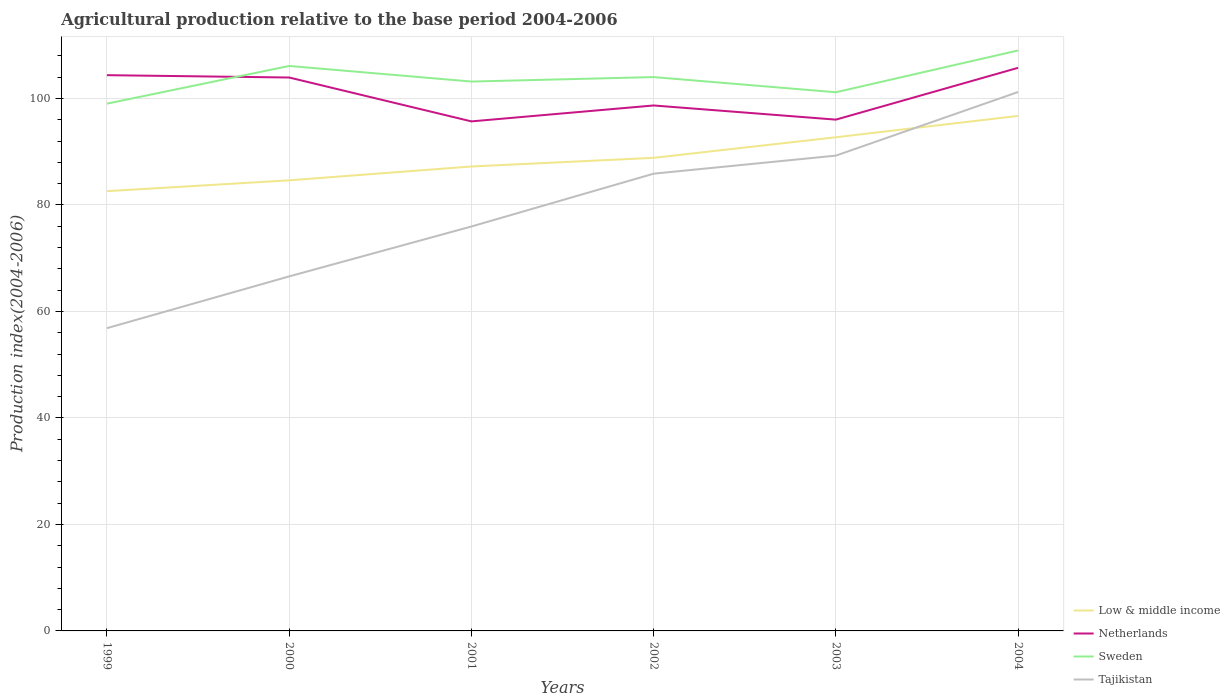Across all years, what is the maximum agricultural production index in Sweden?
Your answer should be very brief. 99.02. In which year was the agricultural production index in Tajikistan maximum?
Give a very brief answer. 1999. What is the total agricultural production index in Sweden in the graph?
Keep it short and to the point. -9.99. What is the difference between the highest and the second highest agricultural production index in Netherlands?
Offer a very short reply. 10.06. What is the difference between the highest and the lowest agricultural production index in Low & middle income?
Offer a very short reply. 3. Is the agricultural production index in Low & middle income strictly greater than the agricultural production index in Netherlands over the years?
Provide a short and direct response. Yes. What is the difference between two consecutive major ticks on the Y-axis?
Ensure brevity in your answer.  20. Are the values on the major ticks of Y-axis written in scientific E-notation?
Keep it short and to the point. No. Does the graph contain any zero values?
Your answer should be very brief. No. Does the graph contain grids?
Make the answer very short. Yes. Where does the legend appear in the graph?
Keep it short and to the point. Bottom right. How many legend labels are there?
Ensure brevity in your answer.  4. How are the legend labels stacked?
Provide a short and direct response. Vertical. What is the title of the graph?
Offer a terse response. Agricultural production relative to the base period 2004-2006. What is the label or title of the X-axis?
Your answer should be compact. Years. What is the label or title of the Y-axis?
Offer a very short reply. Production index(2004-2006). What is the Production index(2004-2006) in Low & middle income in 1999?
Make the answer very short. 82.59. What is the Production index(2004-2006) of Netherlands in 1999?
Your answer should be compact. 104.37. What is the Production index(2004-2006) in Sweden in 1999?
Offer a very short reply. 99.02. What is the Production index(2004-2006) of Tajikistan in 1999?
Ensure brevity in your answer.  56.86. What is the Production index(2004-2006) in Low & middle income in 2000?
Your response must be concise. 84.62. What is the Production index(2004-2006) in Netherlands in 2000?
Provide a succinct answer. 103.93. What is the Production index(2004-2006) of Sweden in 2000?
Provide a short and direct response. 106.1. What is the Production index(2004-2006) in Tajikistan in 2000?
Give a very brief answer. 66.58. What is the Production index(2004-2006) of Low & middle income in 2001?
Give a very brief answer. 87.22. What is the Production index(2004-2006) of Netherlands in 2001?
Offer a terse response. 95.69. What is the Production index(2004-2006) of Sweden in 2001?
Offer a very short reply. 103.17. What is the Production index(2004-2006) in Tajikistan in 2001?
Provide a short and direct response. 75.95. What is the Production index(2004-2006) of Low & middle income in 2002?
Ensure brevity in your answer.  88.85. What is the Production index(2004-2006) in Netherlands in 2002?
Provide a succinct answer. 98.68. What is the Production index(2004-2006) of Sweden in 2002?
Give a very brief answer. 104.01. What is the Production index(2004-2006) of Tajikistan in 2002?
Your answer should be very brief. 85.87. What is the Production index(2004-2006) in Low & middle income in 2003?
Your answer should be compact. 92.71. What is the Production index(2004-2006) of Netherlands in 2003?
Provide a short and direct response. 96.02. What is the Production index(2004-2006) of Sweden in 2003?
Make the answer very short. 101.16. What is the Production index(2004-2006) in Tajikistan in 2003?
Your answer should be very brief. 89.26. What is the Production index(2004-2006) of Low & middle income in 2004?
Your answer should be very brief. 96.72. What is the Production index(2004-2006) of Netherlands in 2004?
Offer a terse response. 105.75. What is the Production index(2004-2006) of Sweden in 2004?
Make the answer very short. 109.01. What is the Production index(2004-2006) in Tajikistan in 2004?
Keep it short and to the point. 101.21. Across all years, what is the maximum Production index(2004-2006) of Low & middle income?
Make the answer very short. 96.72. Across all years, what is the maximum Production index(2004-2006) of Netherlands?
Your answer should be very brief. 105.75. Across all years, what is the maximum Production index(2004-2006) in Sweden?
Make the answer very short. 109.01. Across all years, what is the maximum Production index(2004-2006) of Tajikistan?
Ensure brevity in your answer.  101.21. Across all years, what is the minimum Production index(2004-2006) of Low & middle income?
Your response must be concise. 82.59. Across all years, what is the minimum Production index(2004-2006) of Netherlands?
Keep it short and to the point. 95.69. Across all years, what is the minimum Production index(2004-2006) of Sweden?
Make the answer very short. 99.02. Across all years, what is the minimum Production index(2004-2006) of Tajikistan?
Your answer should be compact. 56.86. What is the total Production index(2004-2006) in Low & middle income in the graph?
Keep it short and to the point. 532.7. What is the total Production index(2004-2006) in Netherlands in the graph?
Offer a terse response. 604.44. What is the total Production index(2004-2006) of Sweden in the graph?
Your answer should be compact. 622.47. What is the total Production index(2004-2006) of Tajikistan in the graph?
Give a very brief answer. 475.73. What is the difference between the Production index(2004-2006) in Low & middle income in 1999 and that in 2000?
Provide a short and direct response. -2.04. What is the difference between the Production index(2004-2006) of Netherlands in 1999 and that in 2000?
Offer a terse response. 0.44. What is the difference between the Production index(2004-2006) in Sweden in 1999 and that in 2000?
Make the answer very short. -7.08. What is the difference between the Production index(2004-2006) in Tajikistan in 1999 and that in 2000?
Provide a succinct answer. -9.72. What is the difference between the Production index(2004-2006) in Low & middle income in 1999 and that in 2001?
Your answer should be very brief. -4.63. What is the difference between the Production index(2004-2006) of Netherlands in 1999 and that in 2001?
Your answer should be compact. 8.68. What is the difference between the Production index(2004-2006) of Sweden in 1999 and that in 2001?
Your answer should be compact. -4.15. What is the difference between the Production index(2004-2006) of Tajikistan in 1999 and that in 2001?
Your answer should be very brief. -19.09. What is the difference between the Production index(2004-2006) in Low & middle income in 1999 and that in 2002?
Offer a terse response. -6.26. What is the difference between the Production index(2004-2006) of Netherlands in 1999 and that in 2002?
Give a very brief answer. 5.69. What is the difference between the Production index(2004-2006) of Sweden in 1999 and that in 2002?
Your answer should be compact. -4.99. What is the difference between the Production index(2004-2006) in Tajikistan in 1999 and that in 2002?
Provide a succinct answer. -29.01. What is the difference between the Production index(2004-2006) of Low & middle income in 1999 and that in 2003?
Give a very brief answer. -10.12. What is the difference between the Production index(2004-2006) in Netherlands in 1999 and that in 2003?
Make the answer very short. 8.35. What is the difference between the Production index(2004-2006) of Sweden in 1999 and that in 2003?
Make the answer very short. -2.14. What is the difference between the Production index(2004-2006) in Tajikistan in 1999 and that in 2003?
Keep it short and to the point. -32.4. What is the difference between the Production index(2004-2006) of Low & middle income in 1999 and that in 2004?
Offer a terse response. -14.13. What is the difference between the Production index(2004-2006) in Netherlands in 1999 and that in 2004?
Provide a short and direct response. -1.38. What is the difference between the Production index(2004-2006) in Sweden in 1999 and that in 2004?
Your response must be concise. -9.99. What is the difference between the Production index(2004-2006) in Tajikistan in 1999 and that in 2004?
Your answer should be compact. -44.35. What is the difference between the Production index(2004-2006) of Low & middle income in 2000 and that in 2001?
Provide a succinct answer. -2.6. What is the difference between the Production index(2004-2006) of Netherlands in 2000 and that in 2001?
Your answer should be compact. 8.24. What is the difference between the Production index(2004-2006) in Sweden in 2000 and that in 2001?
Keep it short and to the point. 2.93. What is the difference between the Production index(2004-2006) of Tajikistan in 2000 and that in 2001?
Keep it short and to the point. -9.37. What is the difference between the Production index(2004-2006) in Low & middle income in 2000 and that in 2002?
Make the answer very short. -4.23. What is the difference between the Production index(2004-2006) in Netherlands in 2000 and that in 2002?
Provide a short and direct response. 5.25. What is the difference between the Production index(2004-2006) of Sweden in 2000 and that in 2002?
Provide a short and direct response. 2.09. What is the difference between the Production index(2004-2006) in Tajikistan in 2000 and that in 2002?
Your answer should be very brief. -19.29. What is the difference between the Production index(2004-2006) in Low & middle income in 2000 and that in 2003?
Ensure brevity in your answer.  -8.09. What is the difference between the Production index(2004-2006) in Netherlands in 2000 and that in 2003?
Ensure brevity in your answer.  7.91. What is the difference between the Production index(2004-2006) in Sweden in 2000 and that in 2003?
Ensure brevity in your answer.  4.94. What is the difference between the Production index(2004-2006) in Tajikistan in 2000 and that in 2003?
Provide a succinct answer. -22.68. What is the difference between the Production index(2004-2006) of Low & middle income in 2000 and that in 2004?
Keep it short and to the point. -12.1. What is the difference between the Production index(2004-2006) in Netherlands in 2000 and that in 2004?
Offer a terse response. -1.82. What is the difference between the Production index(2004-2006) in Sweden in 2000 and that in 2004?
Make the answer very short. -2.91. What is the difference between the Production index(2004-2006) of Tajikistan in 2000 and that in 2004?
Give a very brief answer. -34.63. What is the difference between the Production index(2004-2006) of Low & middle income in 2001 and that in 2002?
Provide a succinct answer. -1.63. What is the difference between the Production index(2004-2006) of Netherlands in 2001 and that in 2002?
Offer a terse response. -2.99. What is the difference between the Production index(2004-2006) of Sweden in 2001 and that in 2002?
Your answer should be compact. -0.84. What is the difference between the Production index(2004-2006) in Tajikistan in 2001 and that in 2002?
Provide a succinct answer. -9.92. What is the difference between the Production index(2004-2006) in Low & middle income in 2001 and that in 2003?
Provide a succinct answer. -5.49. What is the difference between the Production index(2004-2006) of Netherlands in 2001 and that in 2003?
Ensure brevity in your answer.  -0.33. What is the difference between the Production index(2004-2006) in Sweden in 2001 and that in 2003?
Offer a very short reply. 2.01. What is the difference between the Production index(2004-2006) of Tajikistan in 2001 and that in 2003?
Your answer should be compact. -13.31. What is the difference between the Production index(2004-2006) in Low & middle income in 2001 and that in 2004?
Give a very brief answer. -9.5. What is the difference between the Production index(2004-2006) of Netherlands in 2001 and that in 2004?
Offer a terse response. -10.06. What is the difference between the Production index(2004-2006) in Sweden in 2001 and that in 2004?
Your answer should be very brief. -5.84. What is the difference between the Production index(2004-2006) in Tajikistan in 2001 and that in 2004?
Make the answer very short. -25.26. What is the difference between the Production index(2004-2006) of Low & middle income in 2002 and that in 2003?
Your response must be concise. -3.86. What is the difference between the Production index(2004-2006) in Netherlands in 2002 and that in 2003?
Make the answer very short. 2.66. What is the difference between the Production index(2004-2006) in Sweden in 2002 and that in 2003?
Your response must be concise. 2.85. What is the difference between the Production index(2004-2006) of Tajikistan in 2002 and that in 2003?
Your answer should be compact. -3.39. What is the difference between the Production index(2004-2006) of Low & middle income in 2002 and that in 2004?
Provide a short and direct response. -7.87. What is the difference between the Production index(2004-2006) in Netherlands in 2002 and that in 2004?
Your answer should be very brief. -7.07. What is the difference between the Production index(2004-2006) in Sweden in 2002 and that in 2004?
Offer a very short reply. -5. What is the difference between the Production index(2004-2006) in Tajikistan in 2002 and that in 2004?
Provide a short and direct response. -15.34. What is the difference between the Production index(2004-2006) in Low & middle income in 2003 and that in 2004?
Ensure brevity in your answer.  -4.01. What is the difference between the Production index(2004-2006) of Netherlands in 2003 and that in 2004?
Your answer should be compact. -9.73. What is the difference between the Production index(2004-2006) of Sweden in 2003 and that in 2004?
Your answer should be compact. -7.85. What is the difference between the Production index(2004-2006) of Tajikistan in 2003 and that in 2004?
Provide a succinct answer. -11.95. What is the difference between the Production index(2004-2006) of Low & middle income in 1999 and the Production index(2004-2006) of Netherlands in 2000?
Keep it short and to the point. -21.34. What is the difference between the Production index(2004-2006) of Low & middle income in 1999 and the Production index(2004-2006) of Sweden in 2000?
Make the answer very short. -23.51. What is the difference between the Production index(2004-2006) in Low & middle income in 1999 and the Production index(2004-2006) in Tajikistan in 2000?
Your answer should be compact. 16.01. What is the difference between the Production index(2004-2006) of Netherlands in 1999 and the Production index(2004-2006) of Sweden in 2000?
Your answer should be very brief. -1.73. What is the difference between the Production index(2004-2006) of Netherlands in 1999 and the Production index(2004-2006) of Tajikistan in 2000?
Keep it short and to the point. 37.79. What is the difference between the Production index(2004-2006) in Sweden in 1999 and the Production index(2004-2006) in Tajikistan in 2000?
Provide a short and direct response. 32.44. What is the difference between the Production index(2004-2006) in Low & middle income in 1999 and the Production index(2004-2006) in Netherlands in 2001?
Your answer should be very brief. -13.1. What is the difference between the Production index(2004-2006) of Low & middle income in 1999 and the Production index(2004-2006) of Sweden in 2001?
Keep it short and to the point. -20.58. What is the difference between the Production index(2004-2006) of Low & middle income in 1999 and the Production index(2004-2006) of Tajikistan in 2001?
Provide a short and direct response. 6.64. What is the difference between the Production index(2004-2006) in Netherlands in 1999 and the Production index(2004-2006) in Tajikistan in 2001?
Provide a short and direct response. 28.42. What is the difference between the Production index(2004-2006) of Sweden in 1999 and the Production index(2004-2006) of Tajikistan in 2001?
Make the answer very short. 23.07. What is the difference between the Production index(2004-2006) in Low & middle income in 1999 and the Production index(2004-2006) in Netherlands in 2002?
Provide a succinct answer. -16.09. What is the difference between the Production index(2004-2006) in Low & middle income in 1999 and the Production index(2004-2006) in Sweden in 2002?
Provide a succinct answer. -21.42. What is the difference between the Production index(2004-2006) in Low & middle income in 1999 and the Production index(2004-2006) in Tajikistan in 2002?
Offer a terse response. -3.28. What is the difference between the Production index(2004-2006) of Netherlands in 1999 and the Production index(2004-2006) of Sweden in 2002?
Offer a very short reply. 0.36. What is the difference between the Production index(2004-2006) of Sweden in 1999 and the Production index(2004-2006) of Tajikistan in 2002?
Provide a short and direct response. 13.15. What is the difference between the Production index(2004-2006) of Low & middle income in 1999 and the Production index(2004-2006) of Netherlands in 2003?
Ensure brevity in your answer.  -13.43. What is the difference between the Production index(2004-2006) in Low & middle income in 1999 and the Production index(2004-2006) in Sweden in 2003?
Your answer should be compact. -18.57. What is the difference between the Production index(2004-2006) of Low & middle income in 1999 and the Production index(2004-2006) of Tajikistan in 2003?
Keep it short and to the point. -6.67. What is the difference between the Production index(2004-2006) in Netherlands in 1999 and the Production index(2004-2006) in Sweden in 2003?
Provide a succinct answer. 3.21. What is the difference between the Production index(2004-2006) in Netherlands in 1999 and the Production index(2004-2006) in Tajikistan in 2003?
Give a very brief answer. 15.11. What is the difference between the Production index(2004-2006) in Sweden in 1999 and the Production index(2004-2006) in Tajikistan in 2003?
Offer a terse response. 9.76. What is the difference between the Production index(2004-2006) of Low & middle income in 1999 and the Production index(2004-2006) of Netherlands in 2004?
Provide a short and direct response. -23.16. What is the difference between the Production index(2004-2006) in Low & middle income in 1999 and the Production index(2004-2006) in Sweden in 2004?
Provide a succinct answer. -26.42. What is the difference between the Production index(2004-2006) of Low & middle income in 1999 and the Production index(2004-2006) of Tajikistan in 2004?
Ensure brevity in your answer.  -18.62. What is the difference between the Production index(2004-2006) in Netherlands in 1999 and the Production index(2004-2006) in Sweden in 2004?
Your answer should be very brief. -4.64. What is the difference between the Production index(2004-2006) in Netherlands in 1999 and the Production index(2004-2006) in Tajikistan in 2004?
Ensure brevity in your answer.  3.16. What is the difference between the Production index(2004-2006) of Sweden in 1999 and the Production index(2004-2006) of Tajikistan in 2004?
Your response must be concise. -2.19. What is the difference between the Production index(2004-2006) of Low & middle income in 2000 and the Production index(2004-2006) of Netherlands in 2001?
Offer a terse response. -11.07. What is the difference between the Production index(2004-2006) in Low & middle income in 2000 and the Production index(2004-2006) in Sweden in 2001?
Offer a very short reply. -18.55. What is the difference between the Production index(2004-2006) of Low & middle income in 2000 and the Production index(2004-2006) of Tajikistan in 2001?
Keep it short and to the point. 8.67. What is the difference between the Production index(2004-2006) of Netherlands in 2000 and the Production index(2004-2006) of Sweden in 2001?
Offer a terse response. 0.76. What is the difference between the Production index(2004-2006) in Netherlands in 2000 and the Production index(2004-2006) in Tajikistan in 2001?
Give a very brief answer. 27.98. What is the difference between the Production index(2004-2006) of Sweden in 2000 and the Production index(2004-2006) of Tajikistan in 2001?
Give a very brief answer. 30.15. What is the difference between the Production index(2004-2006) of Low & middle income in 2000 and the Production index(2004-2006) of Netherlands in 2002?
Make the answer very short. -14.06. What is the difference between the Production index(2004-2006) of Low & middle income in 2000 and the Production index(2004-2006) of Sweden in 2002?
Offer a terse response. -19.39. What is the difference between the Production index(2004-2006) in Low & middle income in 2000 and the Production index(2004-2006) in Tajikistan in 2002?
Your answer should be compact. -1.25. What is the difference between the Production index(2004-2006) in Netherlands in 2000 and the Production index(2004-2006) in Sweden in 2002?
Give a very brief answer. -0.08. What is the difference between the Production index(2004-2006) in Netherlands in 2000 and the Production index(2004-2006) in Tajikistan in 2002?
Make the answer very short. 18.06. What is the difference between the Production index(2004-2006) of Sweden in 2000 and the Production index(2004-2006) of Tajikistan in 2002?
Your answer should be very brief. 20.23. What is the difference between the Production index(2004-2006) of Low & middle income in 2000 and the Production index(2004-2006) of Netherlands in 2003?
Offer a terse response. -11.4. What is the difference between the Production index(2004-2006) in Low & middle income in 2000 and the Production index(2004-2006) in Sweden in 2003?
Your answer should be very brief. -16.54. What is the difference between the Production index(2004-2006) of Low & middle income in 2000 and the Production index(2004-2006) of Tajikistan in 2003?
Make the answer very short. -4.64. What is the difference between the Production index(2004-2006) of Netherlands in 2000 and the Production index(2004-2006) of Sweden in 2003?
Your answer should be very brief. 2.77. What is the difference between the Production index(2004-2006) of Netherlands in 2000 and the Production index(2004-2006) of Tajikistan in 2003?
Offer a terse response. 14.67. What is the difference between the Production index(2004-2006) in Sweden in 2000 and the Production index(2004-2006) in Tajikistan in 2003?
Your answer should be compact. 16.84. What is the difference between the Production index(2004-2006) in Low & middle income in 2000 and the Production index(2004-2006) in Netherlands in 2004?
Keep it short and to the point. -21.13. What is the difference between the Production index(2004-2006) of Low & middle income in 2000 and the Production index(2004-2006) of Sweden in 2004?
Offer a terse response. -24.39. What is the difference between the Production index(2004-2006) in Low & middle income in 2000 and the Production index(2004-2006) in Tajikistan in 2004?
Give a very brief answer. -16.59. What is the difference between the Production index(2004-2006) in Netherlands in 2000 and the Production index(2004-2006) in Sweden in 2004?
Your answer should be compact. -5.08. What is the difference between the Production index(2004-2006) in Netherlands in 2000 and the Production index(2004-2006) in Tajikistan in 2004?
Offer a terse response. 2.72. What is the difference between the Production index(2004-2006) in Sweden in 2000 and the Production index(2004-2006) in Tajikistan in 2004?
Your answer should be compact. 4.89. What is the difference between the Production index(2004-2006) in Low & middle income in 2001 and the Production index(2004-2006) in Netherlands in 2002?
Provide a short and direct response. -11.46. What is the difference between the Production index(2004-2006) in Low & middle income in 2001 and the Production index(2004-2006) in Sweden in 2002?
Make the answer very short. -16.79. What is the difference between the Production index(2004-2006) of Low & middle income in 2001 and the Production index(2004-2006) of Tajikistan in 2002?
Give a very brief answer. 1.35. What is the difference between the Production index(2004-2006) in Netherlands in 2001 and the Production index(2004-2006) in Sweden in 2002?
Keep it short and to the point. -8.32. What is the difference between the Production index(2004-2006) of Netherlands in 2001 and the Production index(2004-2006) of Tajikistan in 2002?
Provide a succinct answer. 9.82. What is the difference between the Production index(2004-2006) of Sweden in 2001 and the Production index(2004-2006) of Tajikistan in 2002?
Keep it short and to the point. 17.3. What is the difference between the Production index(2004-2006) of Low & middle income in 2001 and the Production index(2004-2006) of Netherlands in 2003?
Ensure brevity in your answer.  -8.8. What is the difference between the Production index(2004-2006) in Low & middle income in 2001 and the Production index(2004-2006) in Sweden in 2003?
Give a very brief answer. -13.94. What is the difference between the Production index(2004-2006) in Low & middle income in 2001 and the Production index(2004-2006) in Tajikistan in 2003?
Make the answer very short. -2.04. What is the difference between the Production index(2004-2006) in Netherlands in 2001 and the Production index(2004-2006) in Sweden in 2003?
Your answer should be very brief. -5.47. What is the difference between the Production index(2004-2006) in Netherlands in 2001 and the Production index(2004-2006) in Tajikistan in 2003?
Your answer should be compact. 6.43. What is the difference between the Production index(2004-2006) of Sweden in 2001 and the Production index(2004-2006) of Tajikistan in 2003?
Provide a succinct answer. 13.91. What is the difference between the Production index(2004-2006) of Low & middle income in 2001 and the Production index(2004-2006) of Netherlands in 2004?
Provide a succinct answer. -18.53. What is the difference between the Production index(2004-2006) in Low & middle income in 2001 and the Production index(2004-2006) in Sweden in 2004?
Keep it short and to the point. -21.79. What is the difference between the Production index(2004-2006) in Low & middle income in 2001 and the Production index(2004-2006) in Tajikistan in 2004?
Your answer should be very brief. -13.99. What is the difference between the Production index(2004-2006) of Netherlands in 2001 and the Production index(2004-2006) of Sweden in 2004?
Give a very brief answer. -13.32. What is the difference between the Production index(2004-2006) of Netherlands in 2001 and the Production index(2004-2006) of Tajikistan in 2004?
Provide a succinct answer. -5.52. What is the difference between the Production index(2004-2006) in Sweden in 2001 and the Production index(2004-2006) in Tajikistan in 2004?
Keep it short and to the point. 1.96. What is the difference between the Production index(2004-2006) of Low & middle income in 2002 and the Production index(2004-2006) of Netherlands in 2003?
Ensure brevity in your answer.  -7.17. What is the difference between the Production index(2004-2006) in Low & middle income in 2002 and the Production index(2004-2006) in Sweden in 2003?
Provide a succinct answer. -12.31. What is the difference between the Production index(2004-2006) in Low & middle income in 2002 and the Production index(2004-2006) in Tajikistan in 2003?
Offer a very short reply. -0.41. What is the difference between the Production index(2004-2006) in Netherlands in 2002 and the Production index(2004-2006) in Sweden in 2003?
Your answer should be very brief. -2.48. What is the difference between the Production index(2004-2006) of Netherlands in 2002 and the Production index(2004-2006) of Tajikistan in 2003?
Offer a terse response. 9.42. What is the difference between the Production index(2004-2006) in Sweden in 2002 and the Production index(2004-2006) in Tajikistan in 2003?
Your response must be concise. 14.75. What is the difference between the Production index(2004-2006) of Low & middle income in 2002 and the Production index(2004-2006) of Netherlands in 2004?
Keep it short and to the point. -16.9. What is the difference between the Production index(2004-2006) of Low & middle income in 2002 and the Production index(2004-2006) of Sweden in 2004?
Ensure brevity in your answer.  -20.16. What is the difference between the Production index(2004-2006) of Low & middle income in 2002 and the Production index(2004-2006) of Tajikistan in 2004?
Keep it short and to the point. -12.36. What is the difference between the Production index(2004-2006) of Netherlands in 2002 and the Production index(2004-2006) of Sweden in 2004?
Make the answer very short. -10.33. What is the difference between the Production index(2004-2006) of Netherlands in 2002 and the Production index(2004-2006) of Tajikistan in 2004?
Ensure brevity in your answer.  -2.53. What is the difference between the Production index(2004-2006) of Sweden in 2002 and the Production index(2004-2006) of Tajikistan in 2004?
Offer a very short reply. 2.8. What is the difference between the Production index(2004-2006) in Low & middle income in 2003 and the Production index(2004-2006) in Netherlands in 2004?
Keep it short and to the point. -13.04. What is the difference between the Production index(2004-2006) of Low & middle income in 2003 and the Production index(2004-2006) of Sweden in 2004?
Give a very brief answer. -16.3. What is the difference between the Production index(2004-2006) of Low & middle income in 2003 and the Production index(2004-2006) of Tajikistan in 2004?
Your response must be concise. -8.5. What is the difference between the Production index(2004-2006) in Netherlands in 2003 and the Production index(2004-2006) in Sweden in 2004?
Ensure brevity in your answer.  -12.99. What is the difference between the Production index(2004-2006) of Netherlands in 2003 and the Production index(2004-2006) of Tajikistan in 2004?
Provide a succinct answer. -5.19. What is the average Production index(2004-2006) of Low & middle income per year?
Give a very brief answer. 88.78. What is the average Production index(2004-2006) of Netherlands per year?
Provide a succinct answer. 100.74. What is the average Production index(2004-2006) in Sweden per year?
Provide a succinct answer. 103.75. What is the average Production index(2004-2006) in Tajikistan per year?
Ensure brevity in your answer.  79.29. In the year 1999, what is the difference between the Production index(2004-2006) of Low & middle income and Production index(2004-2006) of Netherlands?
Make the answer very short. -21.78. In the year 1999, what is the difference between the Production index(2004-2006) in Low & middle income and Production index(2004-2006) in Sweden?
Offer a very short reply. -16.43. In the year 1999, what is the difference between the Production index(2004-2006) of Low & middle income and Production index(2004-2006) of Tajikistan?
Your answer should be very brief. 25.73. In the year 1999, what is the difference between the Production index(2004-2006) in Netherlands and Production index(2004-2006) in Sweden?
Provide a succinct answer. 5.35. In the year 1999, what is the difference between the Production index(2004-2006) in Netherlands and Production index(2004-2006) in Tajikistan?
Keep it short and to the point. 47.51. In the year 1999, what is the difference between the Production index(2004-2006) in Sweden and Production index(2004-2006) in Tajikistan?
Keep it short and to the point. 42.16. In the year 2000, what is the difference between the Production index(2004-2006) of Low & middle income and Production index(2004-2006) of Netherlands?
Offer a very short reply. -19.31. In the year 2000, what is the difference between the Production index(2004-2006) of Low & middle income and Production index(2004-2006) of Sweden?
Your response must be concise. -21.48. In the year 2000, what is the difference between the Production index(2004-2006) in Low & middle income and Production index(2004-2006) in Tajikistan?
Offer a terse response. 18.04. In the year 2000, what is the difference between the Production index(2004-2006) in Netherlands and Production index(2004-2006) in Sweden?
Keep it short and to the point. -2.17. In the year 2000, what is the difference between the Production index(2004-2006) in Netherlands and Production index(2004-2006) in Tajikistan?
Your answer should be very brief. 37.35. In the year 2000, what is the difference between the Production index(2004-2006) in Sweden and Production index(2004-2006) in Tajikistan?
Your answer should be compact. 39.52. In the year 2001, what is the difference between the Production index(2004-2006) in Low & middle income and Production index(2004-2006) in Netherlands?
Your answer should be compact. -8.47. In the year 2001, what is the difference between the Production index(2004-2006) in Low & middle income and Production index(2004-2006) in Sweden?
Provide a succinct answer. -15.95. In the year 2001, what is the difference between the Production index(2004-2006) in Low & middle income and Production index(2004-2006) in Tajikistan?
Offer a very short reply. 11.27. In the year 2001, what is the difference between the Production index(2004-2006) in Netherlands and Production index(2004-2006) in Sweden?
Provide a short and direct response. -7.48. In the year 2001, what is the difference between the Production index(2004-2006) of Netherlands and Production index(2004-2006) of Tajikistan?
Give a very brief answer. 19.74. In the year 2001, what is the difference between the Production index(2004-2006) in Sweden and Production index(2004-2006) in Tajikistan?
Your response must be concise. 27.22. In the year 2002, what is the difference between the Production index(2004-2006) of Low & middle income and Production index(2004-2006) of Netherlands?
Provide a short and direct response. -9.83. In the year 2002, what is the difference between the Production index(2004-2006) in Low & middle income and Production index(2004-2006) in Sweden?
Give a very brief answer. -15.16. In the year 2002, what is the difference between the Production index(2004-2006) of Low & middle income and Production index(2004-2006) of Tajikistan?
Keep it short and to the point. 2.98. In the year 2002, what is the difference between the Production index(2004-2006) of Netherlands and Production index(2004-2006) of Sweden?
Your answer should be compact. -5.33. In the year 2002, what is the difference between the Production index(2004-2006) in Netherlands and Production index(2004-2006) in Tajikistan?
Keep it short and to the point. 12.81. In the year 2002, what is the difference between the Production index(2004-2006) of Sweden and Production index(2004-2006) of Tajikistan?
Keep it short and to the point. 18.14. In the year 2003, what is the difference between the Production index(2004-2006) in Low & middle income and Production index(2004-2006) in Netherlands?
Offer a terse response. -3.31. In the year 2003, what is the difference between the Production index(2004-2006) of Low & middle income and Production index(2004-2006) of Sweden?
Provide a short and direct response. -8.45. In the year 2003, what is the difference between the Production index(2004-2006) in Low & middle income and Production index(2004-2006) in Tajikistan?
Give a very brief answer. 3.45. In the year 2003, what is the difference between the Production index(2004-2006) in Netherlands and Production index(2004-2006) in Sweden?
Offer a terse response. -5.14. In the year 2003, what is the difference between the Production index(2004-2006) in Netherlands and Production index(2004-2006) in Tajikistan?
Give a very brief answer. 6.76. In the year 2003, what is the difference between the Production index(2004-2006) in Sweden and Production index(2004-2006) in Tajikistan?
Offer a very short reply. 11.9. In the year 2004, what is the difference between the Production index(2004-2006) in Low & middle income and Production index(2004-2006) in Netherlands?
Ensure brevity in your answer.  -9.03. In the year 2004, what is the difference between the Production index(2004-2006) in Low & middle income and Production index(2004-2006) in Sweden?
Your answer should be very brief. -12.29. In the year 2004, what is the difference between the Production index(2004-2006) of Low & middle income and Production index(2004-2006) of Tajikistan?
Keep it short and to the point. -4.49. In the year 2004, what is the difference between the Production index(2004-2006) of Netherlands and Production index(2004-2006) of Sweden?
Provide a short and direct response. -3.26. In the year 2004, what is the difference between the Production index(2004-2006) of Netherlands and Production index(2004-2006) of Tajikistan?
Your answer should be very brief. 4.54. In the year 2004, what is the difference between the Production index(2004-2006) in Sweden and Production index(2004-2006) in Tajikistan?
Ensure brevity in your answer.  7.8. What is the ratio of the Production index(2004-2006) in Low & middle income in 1999 to that in 2000?
Offer a terse response. 0.98. What is the ratio of the Production index(2004-2006) of Sweden in 1999 to that in 2000?
Your response must be concise. 0.93. What is the ratio of the Production index(2004-2006) of Tajikistan in 1999 to that in 2000?
Provide a short and direct response. 0.85. What is the ratio of the Production index(2004-2006) in Low & middle income in 1999 to that in 2001?
Provide a succinct answer. 0.95. What is the ratio of the Production index(2004-2006) of Netherlands in 1999 to that in 2001?
Offer a very short reply. 1.09. What is the ratio of the Production index(2004-2006) in Sweden in 1999 to that in 2001?
Your answer should be compact. 0.96. What is the ratio of the Production index(2004-2006) of Tajikistan in 1999 to that in 2001?
Give a very brief answer. 0.75. What is the ratio of the Production index(2004-2006) in Low & middle income in 1999 to that in 2002?
Offer a terse response. 0.93. What is the ratio of the Production index(2004-2006) of Netherlands in 1999 to that in 2002?
Offer a terse response. 1.06. What is the ratio of the Production index(2004-2006) in Sweden in 1999 to that in 2002?
Your response must be concise. 0.95. What is the ratio of the Production index(2004-2006) of Tajikistan in 1999 to that in 2002?
Provide a short and direct response. 0.66. What is the ratio of the Production index(2004-2006) of Low & middle income in 1999 to that in 2003?
Make the answer very short. 0.89. What is the ratio of the Production index(2004-2006) in Netherlands in 1999 to that in 2003?
Provide a short and direct response. 1.09. What is the ratio of the Production index(2004-2006) of Sweden in 1999 to that in 2003?
Your answer should be compact. 0.98. What is the ratio of the Production index(2004-2006) of Tajikistan in 1999 to that in 2003?
Your answer should be compact. 0.64. What is the ratio of the Production index(2004-2006) of Low & middle income in 1999 to that in 2004?
Provide a succinct answer. 0.85. What is the ratio of the Production index(2004-2006) of Sweden in 1999 to that in 2004?
Keep it short and to the point. 0.91. What is the ratio of the Production index(2004-2006) of Tajikistan in 1999 to that in 2004?
Provide a short and direct response. 0.56. What is the ratio of the Production index(2004-2006) of Low & middle income in 2000 to that in 2001?
Ensure brevity in your answer.  0.97. What is the ratio of the Production index(2004-2006) in Netherlands in 2000 to that in 2001?
Your answer should be very brief. 1.09. What is the ratio of the Production index(2004-2006) of Sweden in 2000 to that in 2001?
Ensure brevity in your answer.  1.03. What is the ratio of the Production index(2004-2006) in Tajikistan in 2000 to that in 2001?
Offer a terse response. 0.88. What is the ratio of the Production index(2004-2006) in Netherlands in 2000 to that in 2002?
Your answer should be compact. 1.05. What is the ratio of the Production index(2004-2006) in Sweden in 2000 to that in 2002?
Your answer should be very brief. 1.02. What is the ratio of the Production index(2004-2006) of Tajikistan in 2000 to that in 2002?
Make the answer very short. 0.78. What is the ratio of the Production index(2004-2006) in Low & middle income in 2000 to that in 2003?
Offer a very short reply. 0.91. What is the ratio of the Production index(2004-2006) in Netherlands in 2000 to that in 2003?
Your response must be concise. 1.08. What is the ratio of the Production index(2004-2006) of Sweden in 2000 to that in 2003?
Give a very brief answer. 1.05. What is the ratio of the Production index(2004-2006) in Tajikistan in 2000 to that in 2003?
Make the answer very short. 0.75. What is the ratio of the Production index(2004-2006) in Low & middle income in 2000 to that in 2004?
Ensure brevity in your answer.  0.87. What is the ratio of the Production index(2004-2006) of Netherlands in 2000 to that in 2004?
Give a very brief answer. 0.98. What is the ratio of the Production index(2004-2006) of Sweden in 2000 to that in 2004?
Offer a terse response. 0.97. What is the ratio of the Production index(2004-2006) in Tajikistan in 2000 to that in 2004?
Offer a terse response. 0.66. What is the ratio of the Production index(2004-2006) of Low & middle income in 2001 to that in 2002?
Give a very brief answer. 0.98. What is the ratio of the Production index(2004-2006) of Netherlands in 2001 to that in 2002?
Your response must be concise. 0.97. What is the ratio of the Production index(2004-2006) in Tajikistan in 2001 to that in 2002?
Provide a succinct answer. 0.88. What is the ratio of the Production index(2004-2006) in Low & middle income in 2001 to that in 2003?
Offer a terse response. 0.94. What is the ratio of the Production index(2004-2006) of Netherlands in 2001 to that in 2003?
Offer a terse response. 1. What is the ratio of the Production index(2004-2006) in Sweden in 2001 to that in 2003?
Your answer should be very brief. 1.02. What is the ratio of the Production index(2004-2006) in Tajikistan in 2001 to that in 2003?
Your answer should be very brief. 0.85. What is the ratio of the Production index(2004-2006) in Low & middle income in 2001 to that in 2004?
Give a very brief answer. 0.9. What is the ratio of the Production index(2004-2006) of Netherlands in 2001 to that in 2004?
Give a very brief answer. 0.9. What is the ratio of the Production index(2004-2006) of Sweden in 2001 to that in 2004?
Offer a terse response. 0.95. What is the ratio of the Production index(2004-2006) in Tajikistan in 2001 to that in 2004?
Ensure brevity in your answer.  0.75. What is the ratio of the Production index(2004-2006) of Netherlands in 2002 to that in 2003?
Offer a very short reply. 1.03. What is the ratio of the Production index(2004-2006) of Sweden in 2002 to that in 2003?
Offer a terse response. 1.03. What is the ratio of the Production index(2004-2006) in Low & middle income in 2002 to that in 2004?
Offer a very short reply. 0.92. What is the ratio of the Production index(2004-2006) of Netherlands in 2002 to that in 2004?
Give a very brief answer. 0.93. What is the ratio of the Production index(2004-2006) of Sweden in 2002 to that in 2004?
Your answer should be very brief. 0.95. What is the ratio of the Production index(2004-2006) in Tajikistan in 2002 to that in 2004?
Provide a short and direct response. 0.85. What is the ratio of the Production index(2004-2006) in Low & middle income in 2003 to that in 2004?
Offer a terse response. 0.96. What is the ratio of the Production index(2004-2006) of Netherlands in 2003 to that in 2004?
Provide a short and direct response. 0.91. What is the ratio of the Production index(2004-2006) of Sweden in 2003 to that in 2004?
Provide a short and direct response. 0.93. What is the ratio of the Production index(2004-2006) in Tajikistan in 2003 to that in 2004?
Ensure brevity in your answer.  0.88. What is the difference between the highest and the second highest Production index(2004-2006) in Low & middle income?
Your answer should be compact. 4.01. What is the difference between the highest and the second highest Production index(2004-2006) in Netherlands?
Ensure brevity in your answer.  1.38. What is the difference between the highest and the second highest Production index(2004-2006) of Sweden?
Offer a very short reply. 2.91. What is the difference between the highest and the second highest Production index(2004-2006) of Tajikistan?
Your answer should be compact. 11.95. What is the difference between the highest and the lowest Production index(2004-2006) of Low & middle income?
Ensure brevity in your answer.  14.13. What is the difference between the highest and the lowest Production index(2004-2006) in Netherlands?
Offer a very short reply. 10.06. What is the difference between the highest and the lowest Production index(2004-2006) of Sweden?
Provide a short and direct response. 9.99. What is the difference between the highest and the lowest Production index(2004-2006) in Tajikistan?
Provide a short and direct response. 44.35. 